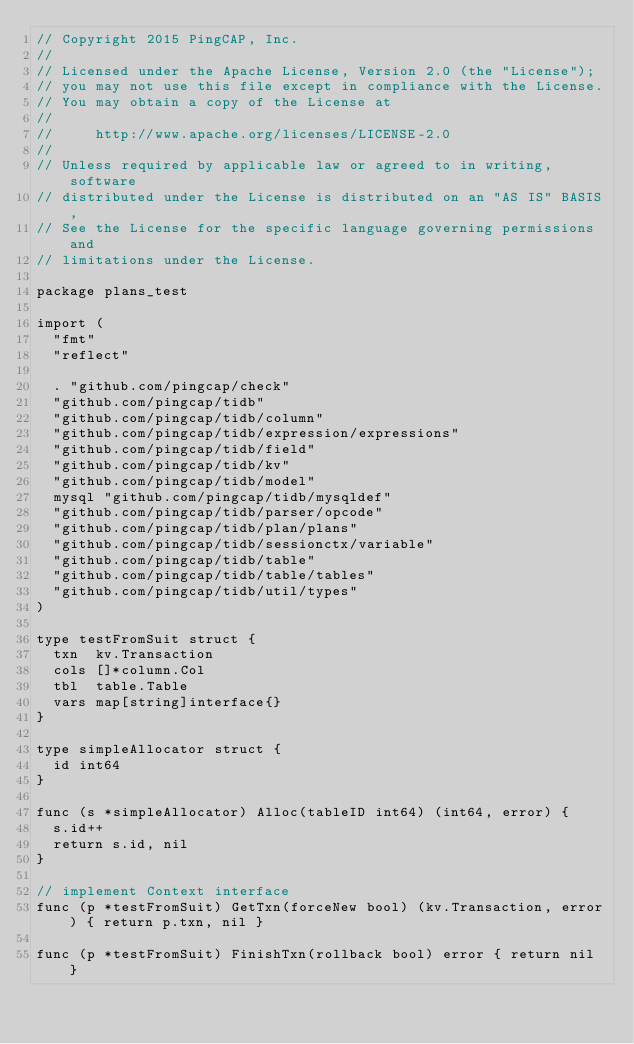Convert code to text. <code><loc_0><loc_0><loc_500><loc_500><_Go_>// Copyright 2015 PingCAP, Inc.
//
// Licensed under the Apache License, Version 2.0 (the "License");
// you may not use this file except in compliance with the License.
// You may obtain a copy of the License at
//
//     http://www.apache.org/licenses/LICENSE-2.0
//
// Unless required by applicable law or agreed to in writing, software
// distributed under the License is distributed on an "AS IS" BASIS,
// See the License for the specific language governing permissions and
// limitations under the License.

package plans_test

import (
	"fmt"
	"reflect"

	. "github.com/pingcap/check"
	"github.com/pingcap/tidb"
	"github.com/pingcap/tidb/column"
	"github.com/pingcap/tidb/expression/expressions"
	"github.com/pingcap/tidb/field"
	"github.com/pingcap/tidb/kv"
	"github.com/pingcap/tidb/model"
	mysql "github.com/pingcap/tidb/mysqldef"
	"github.com/pingcap/tidb/parser/opcode"
	"github.com/pingcap/tidb/plan/plans"
	"github.com/pingcap/tidb/sessionctx/variable"
	"github.com/pingcap/tidb/table"
	"github.com/pingcap/tidb/table/tables"
	"github.com/pingcap/tidb/util/types"
)

type testFromSuit struct {
	txn  kv.Transaction
	cols []*column.Col
	tbl  table.Table
	vars map[string]interface{}
}

type simpleAllocator struct {
	id int64
}

func (s *simpleAllocator) Alloc(tableID int64) (int64, error) {
	s.id++
	return s.id, nil
}

// implement Context interface
func (p *testFromSuit) GetTxn(forceNew bool) (kv.Transaction, error) { return p.txn, nil }

func (p *testFromSuit) FinishTxn(rollback bool) error { return nil }
</code> 